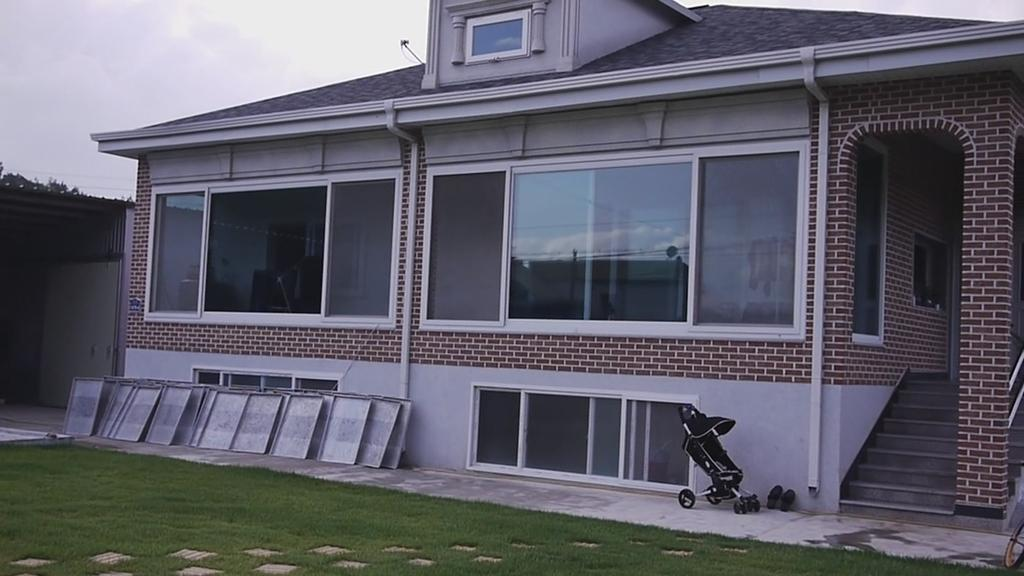What type of building is visible in the image? There is a house in the image. What object is placed in front of the house? There is a baby stroller in front of the house. Where is the baby stroller positioned in relation to the house? The baby stroller is kept in front of a wall. What type of surface is in front of the baby stroller? There is a grass surface in front of the stroller. What type of match is being played in the scene? There is no match or any reference to a game in the image; it features a house, a baby stroller, and a grass surface. How many soldiers are present in the army scene in the image? There is no army or soldiers present in the image. 